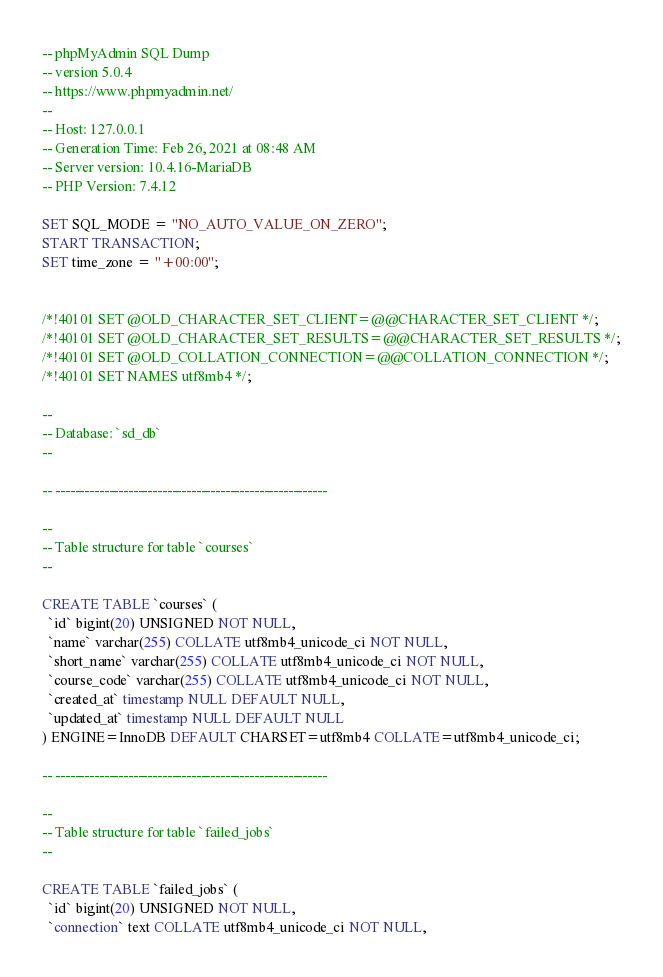<code> <loc_0><loc_0><loc_500><loc_500><_SQL_>-- phpMyAdmin SQL Dump
-- version 5.0.4
-- https://www.phpmyadmin.net/
--
-- Host: 127.0.0.1
-- Generation Time: Feb 26, 2021 at 08:48 AM
-- Server version: 10.4.16-MariaDB
-- PHP Version: 7.4.12

SET SQL_MODE = "NO_AUTO_VALUE_ON_ZERO";
START TRANSACTION;
SET time_zone = "+00:00";


/*!40101 SET @OLD_CHARACTER_SET_CLIENT=@@CHARACTER_SET_CLIENT */;
/*!40101 SET @OLD_CHARACTER_SET_RESULTS=@@CHARACTER_SET_RESULTS */;
/*!40101 SET @OLD_COLLATION_CONNECTION=@@COLLATION_CONNECTION */;
/*!40101 SET NAMES utf8mb4 */;

--
-- Database: `sd_db`
--

-- --------------------------------------------------------

--
-- Table structure for table `courses`
--

CREATE TABLE `courses` (
  `id` bigint(20) UNSIGNED NOT NULL,
  `name` varchar(255) COLLATE utf8mb4_unicode_ci NOT NULL,
  `short_name` varchar(255) COLLATE utf8mb4_unicode_ci NOT NULL,
  `course_code` varchar(255) COLLATE utf8mb4_unicode_ci NOT NULL,
  `created_at` timestamp NULL DEFAULT NULL,
  `updated_at` timestamp NULL DEFAULT NULL
) ENGINE=InnoDB DEFAULT CHARSET=utf8mb4 COLLATE=utf8mb4_unicode_ci;

-- --------------------------------------------------------

--
-- Table structure for table `failed_jobs`
--

CREATE TABLE `failed_jobs` (
  `id` bigint(20) UNSIGNED NOT NULL,
  `connection` text COLLATE utf8mb4_unicode_ci NOT NULL,</code> 